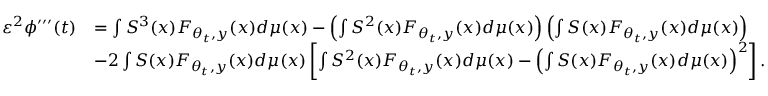Convert formula to latex. <formula><loc_0><loc_0><loc_500><loc_500>\begin{array} { r l } { { \varepsilon } ^ { 2 } \phi ^ { \prime \prime \prime } ( t ) } & { = \int S ^ { 3 } ( x ) F _ { \theta _ { t } , y } ( x ) d \mu ( x ) - \left ( \int S ^ { 2 } ( x ) F _ { \theta _ { t } , y } ( x ) d \mu ( x ) \right ) \left ( \int S ( x ) F _ { \theta _ { t } , y } ( x ) d \mu ( x ) \right ) } \\ & { - 2 \int S ( x ) F _ { \theta _ { t } , y } ( x ) d \mu ( x ) \left [ \int S ^ { 2 } ( x ) F _ { \theta _ { t } , y } ( x ) d \mu ( x ) - \left ( \int S ( x ) F _ { \theta _ { t } , y } ( x ) d \mu ( x ) \right ) ^ { 2 } \right ] . } \end{array}</formula> 